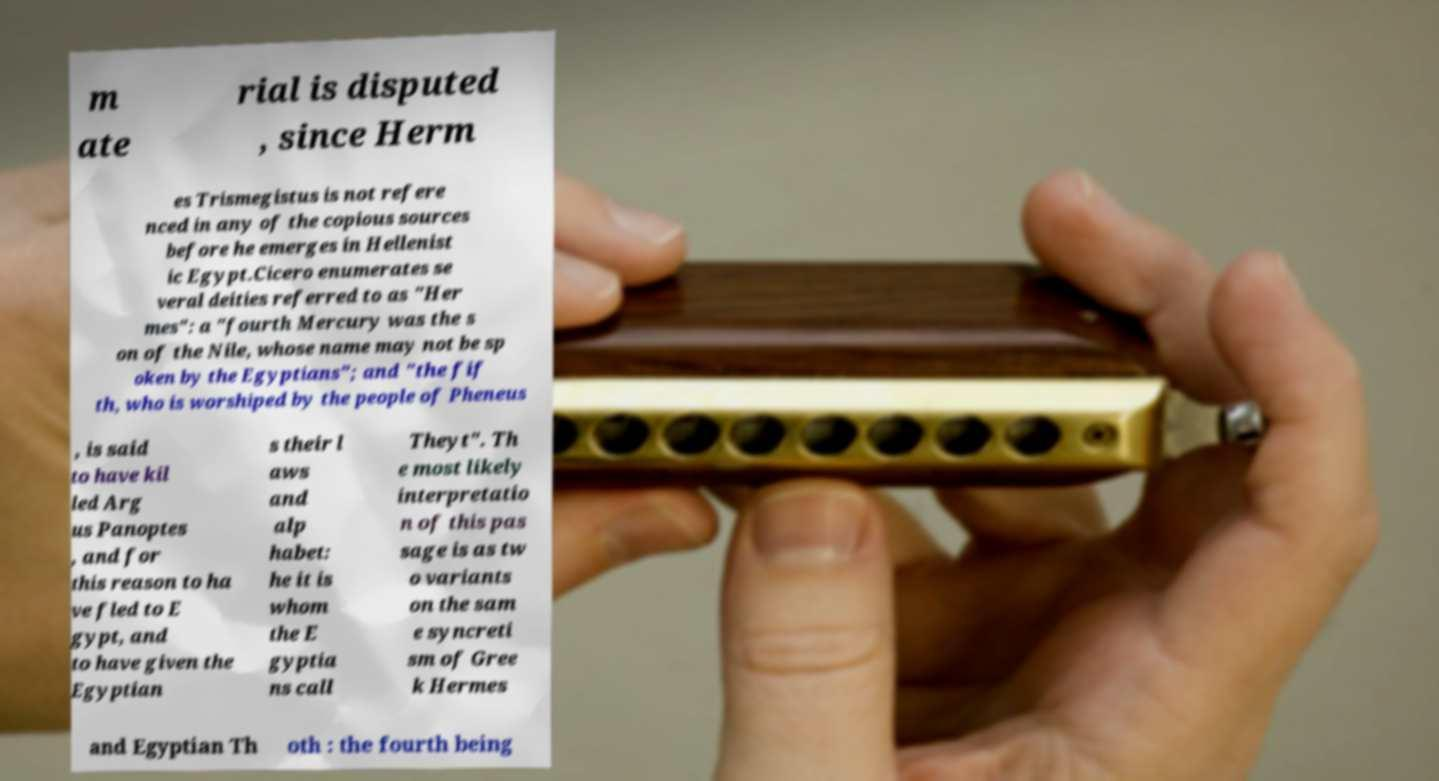For documentation purposes, I need the text within this image transcribed. Could you provide that? m ate rial is disputed , since Herm es Trismegistus is not refere nced in any of the copious sources before he emerges in Hellenist ic Egypt.Cicero enumerates se veral deities referred to as "Her mes": a "fourth Mercury was the s on of the Nile, whose name may not be sp oken by the Egyptians"; and "the fif th, who is worshiped by the people of Pheneus , is said to have kil led Arg us Panoptes , and for this reason to ha ve fled to E gypt, and to have given the Egyptian s their l aws and alp habet: he it is whom the E gyptia ns call Theyt". Th e most likely interpretatio n of this pas sage is as tw o variants on the sam e syncreti sm of Gree k Hermes and Egyptian Th oth : the fourth being 